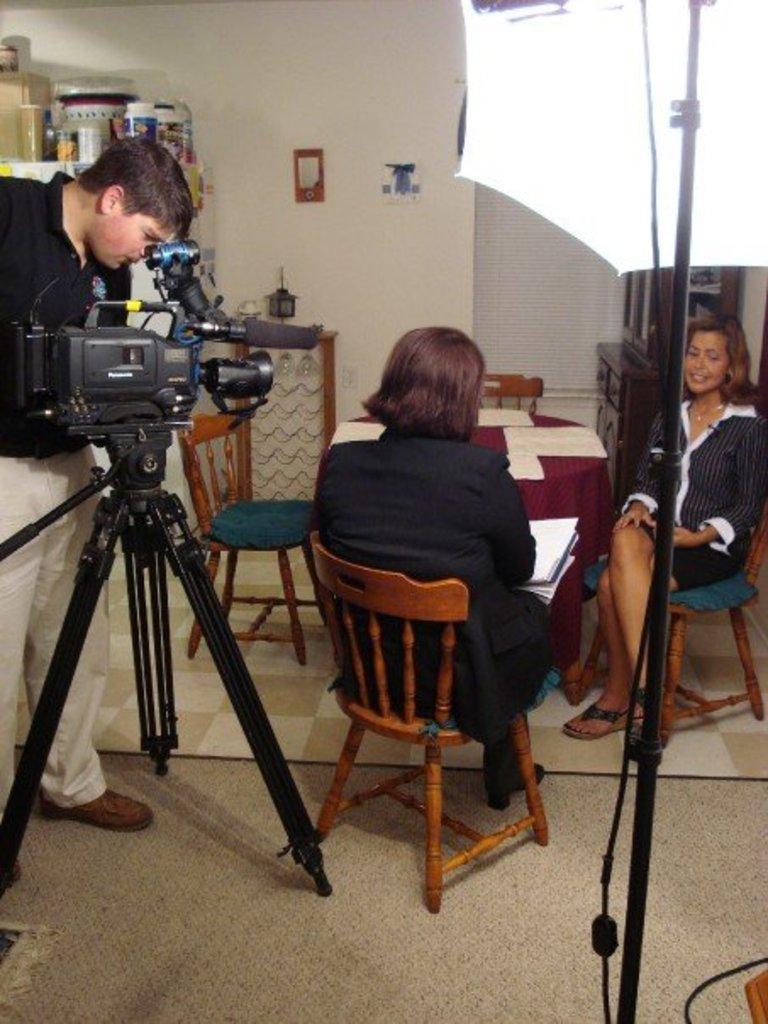Can you describe this image briefly? This picture is taken inside a room. Here are three people, one man standing and carrying video camera and he is taking videos that video camera and two women sitting on the chair and the woman sitting in the middle of this picture, is holding papers in her hands. The woman on the right corner of this picture is smiling. Behind them we see a table and the chair and wall and also cupboard which is brown in color. 